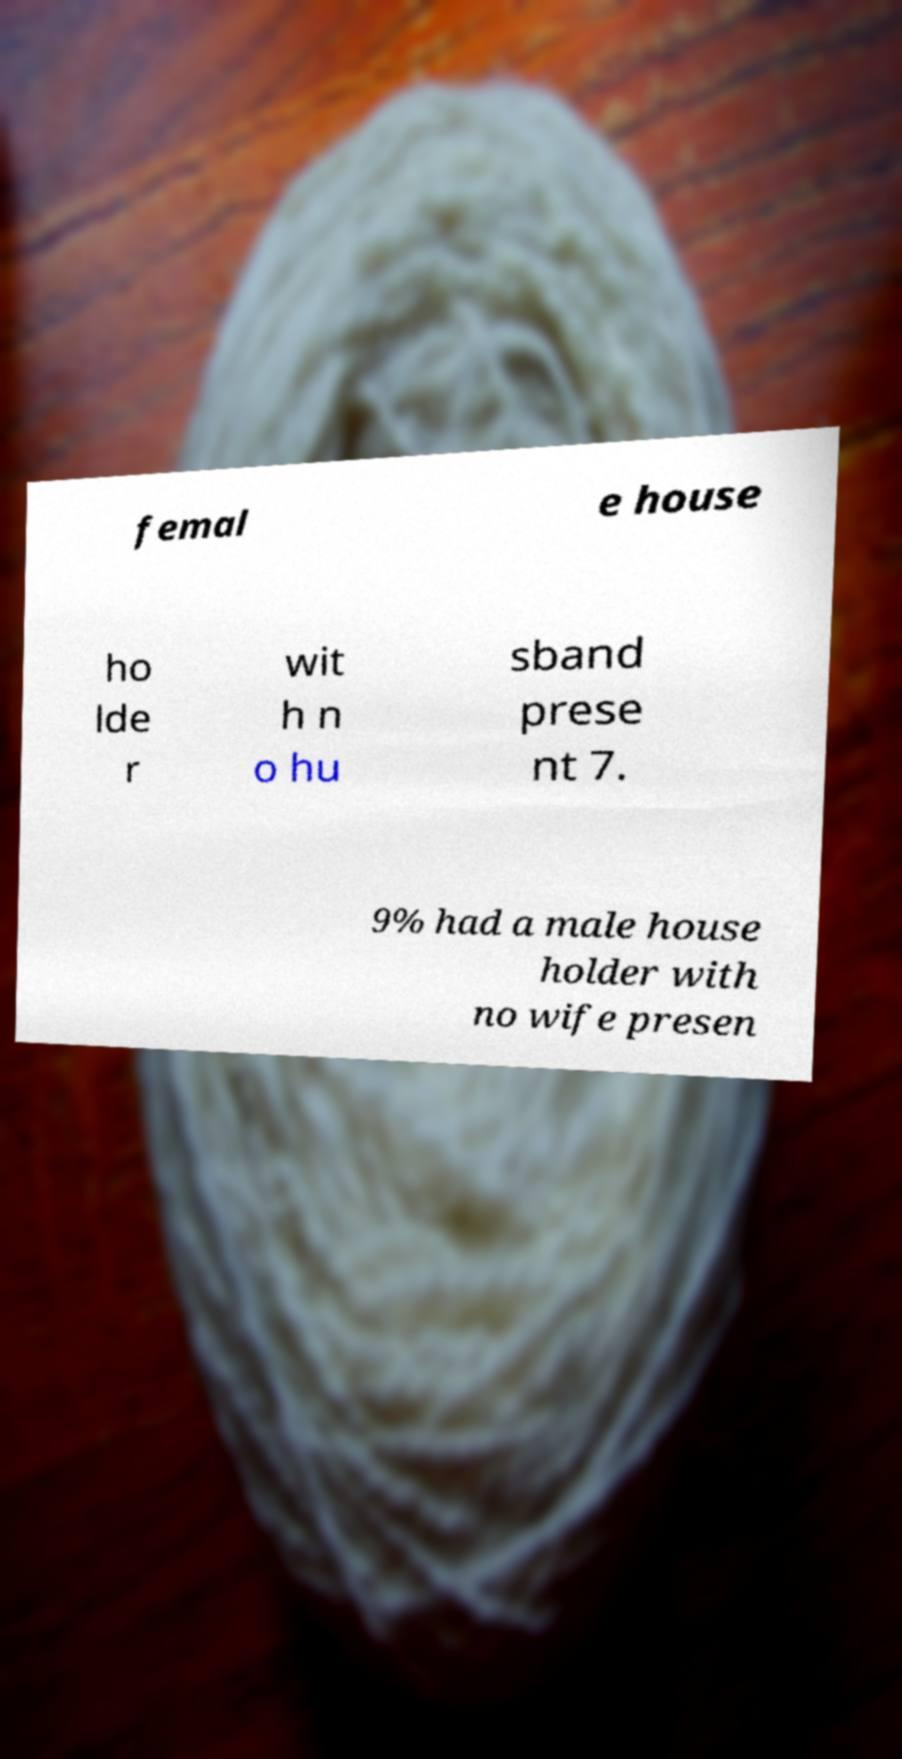There's text embedded in this image that I need extracted. Can you transcribe it verbatim? femal e house ho lde r wit h n o hu sband prese nt 7. 9% had a male house holder with no wife presen 